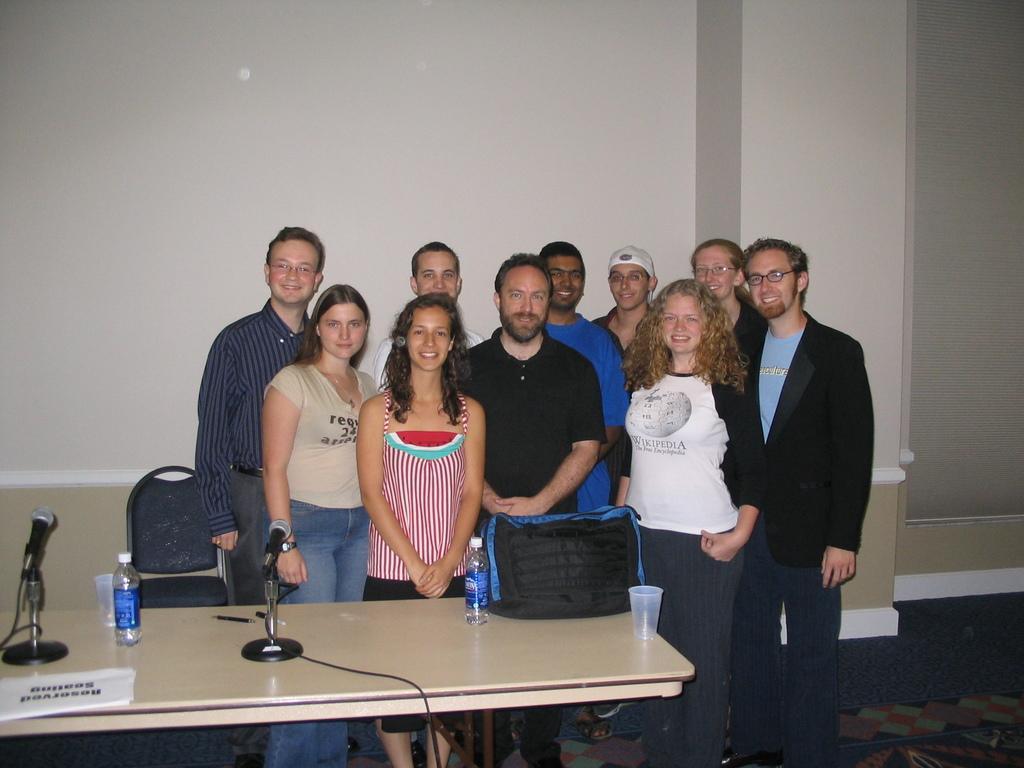Can you describe this image briefly? In this image I can see few people are standing. I can also see smile on their faces. Here I can see two of them are wearing specs and one is wearing a cap. I can also see a chair and a table. On this table I can see a glass,few bottles and few mics. 